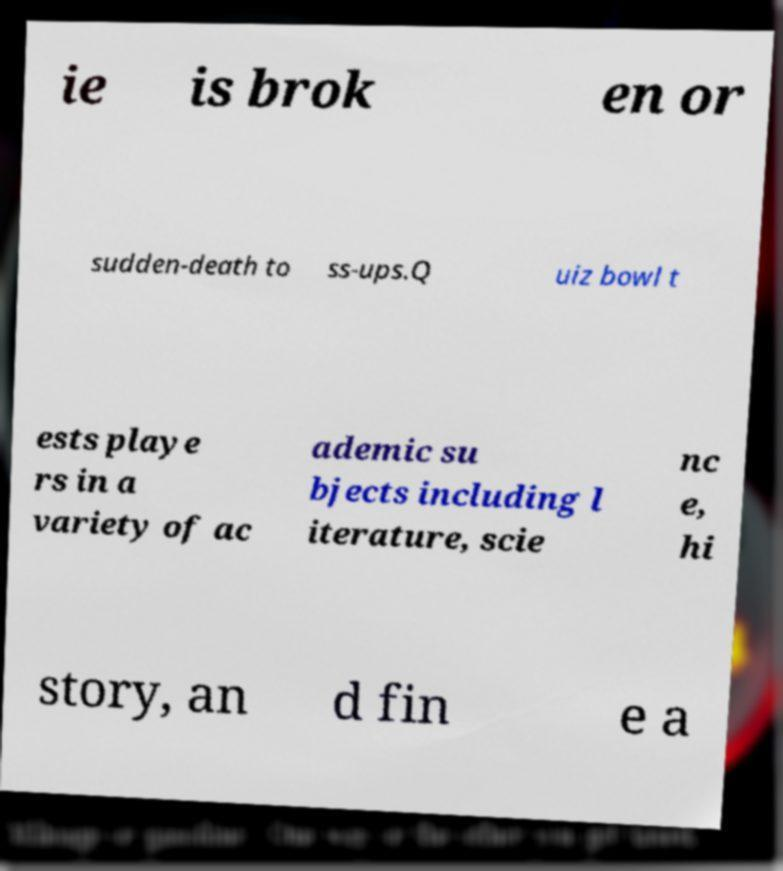Please read and relay the text visible in this image. What does it say? ie is brok en or sudden-death to ss-ups.Q uiz bowl t ests playe rs in a variety of ac ademic su bjects including l iterature, scie nc e, hi story, an d fin e a 